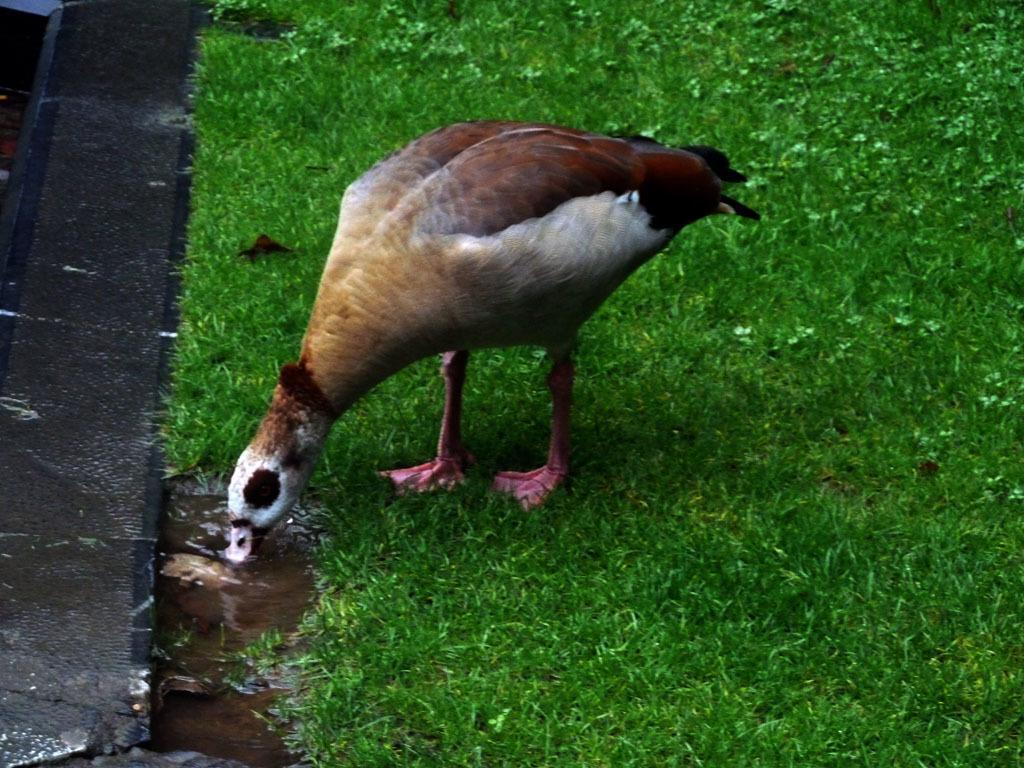Describe this image in one or two sentences. In this image a bird is standing on the grassland. Left bottom there is water. Bird is drinking water. Left side there is a floor. 